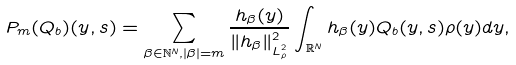<formula> <loc_0><loc_0><loc_500><loc_500>P _ { m } ( Q _ { b } ) ( y , s ) = \sum _ { \beta \in \mathbb { N } ^ { N } , | \beta | = m } \frac { h _ { \beta } ( y ) } { \| h _ { \beta } \| ^ { 2 } _ { L ^ { 2 } _ { \rho } } } \int _ { \mathbb { R } ^ { N } } h _ { \beta } ( y ) Q _ { b } ( y , s ) \rho ( y ) d y ,</formula> 